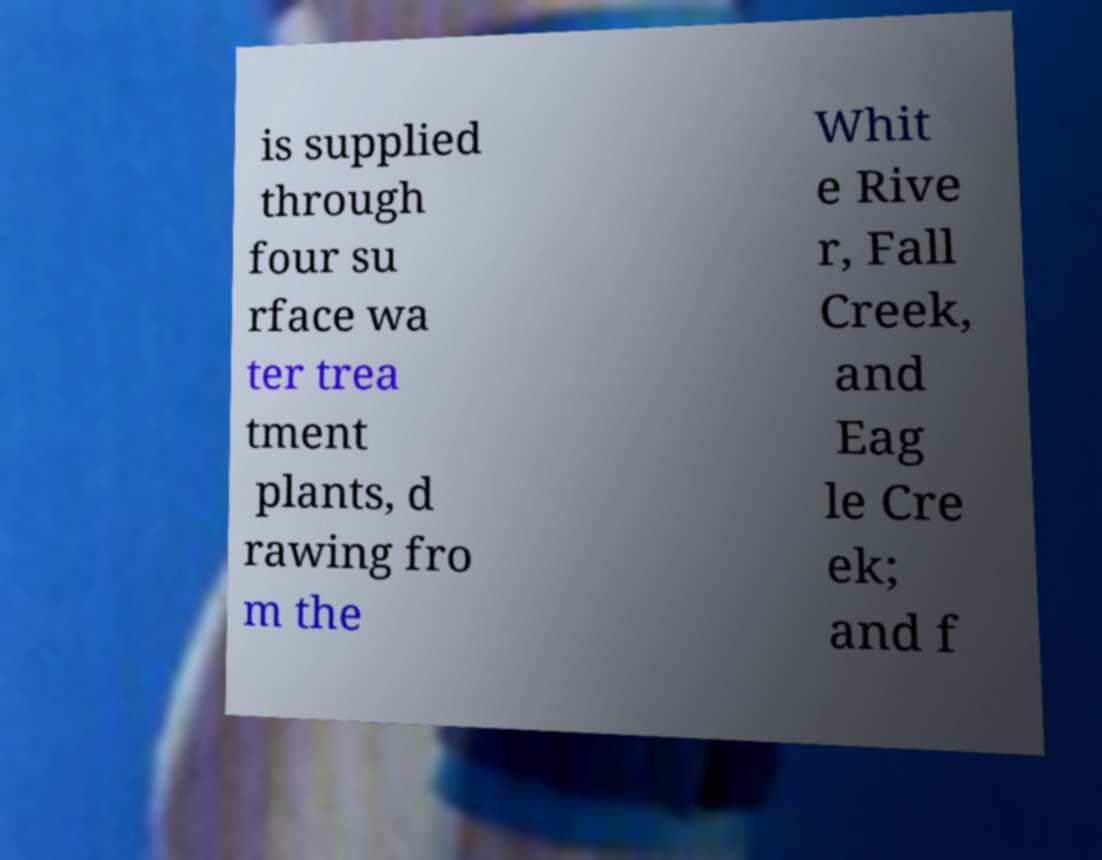Can you read and provide the text displayed in the image?This photo seems to have some interesting text. Can you extract and type it out for me? is supplied through four su rface wa ter trea tment plants, d rawing fro m the Whit e Rive r, Fall Creek, and Eag le Cre ek; and f 